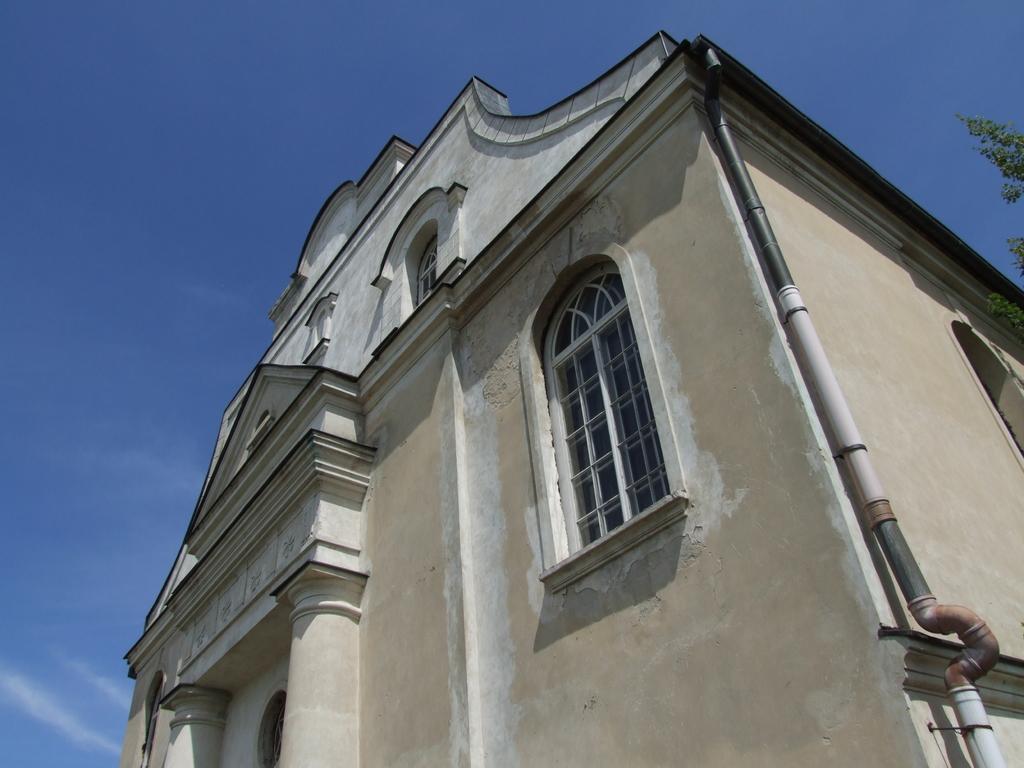Can you describe this image briefly? In this image there is a building with the window. At the top there is the sky. On the right side there is a tree. There is a pipe attached to the building. 